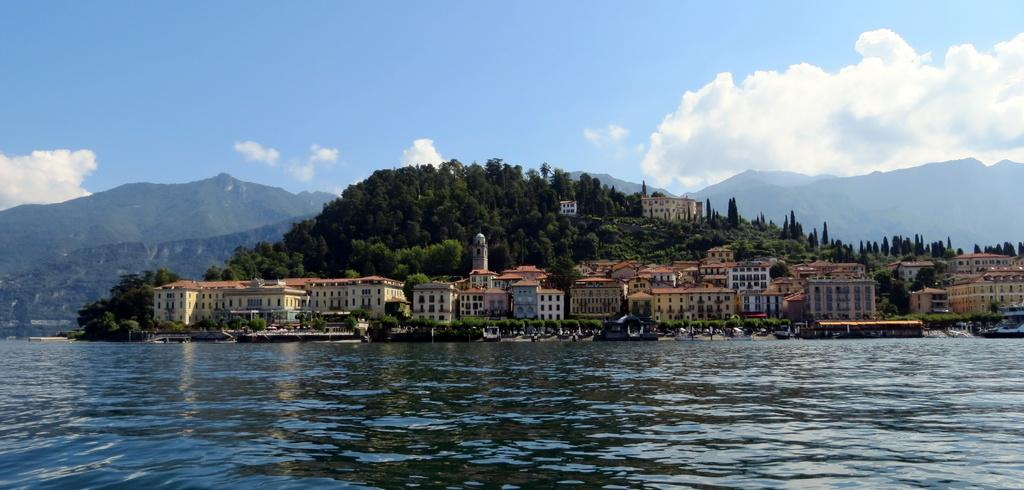What is present on the water in the image? There are ships on the water in the image. What type of structures can be seen in the image? There are buildings in the image. What type of vegetation is present in the image? There are trees in the image. What architectural feature is visible in the image? There are windows in the image. What type of natural landform is visible in the image? There are mountains in the image. What is visible in the background of the image? The sky with clouds is visible in the background of the image. Where is the cook preparing food in the image? There is no cook or food preparation visible in the image. What type of camera can be seen capturing the scene in the image? There is no camera present in the image. 